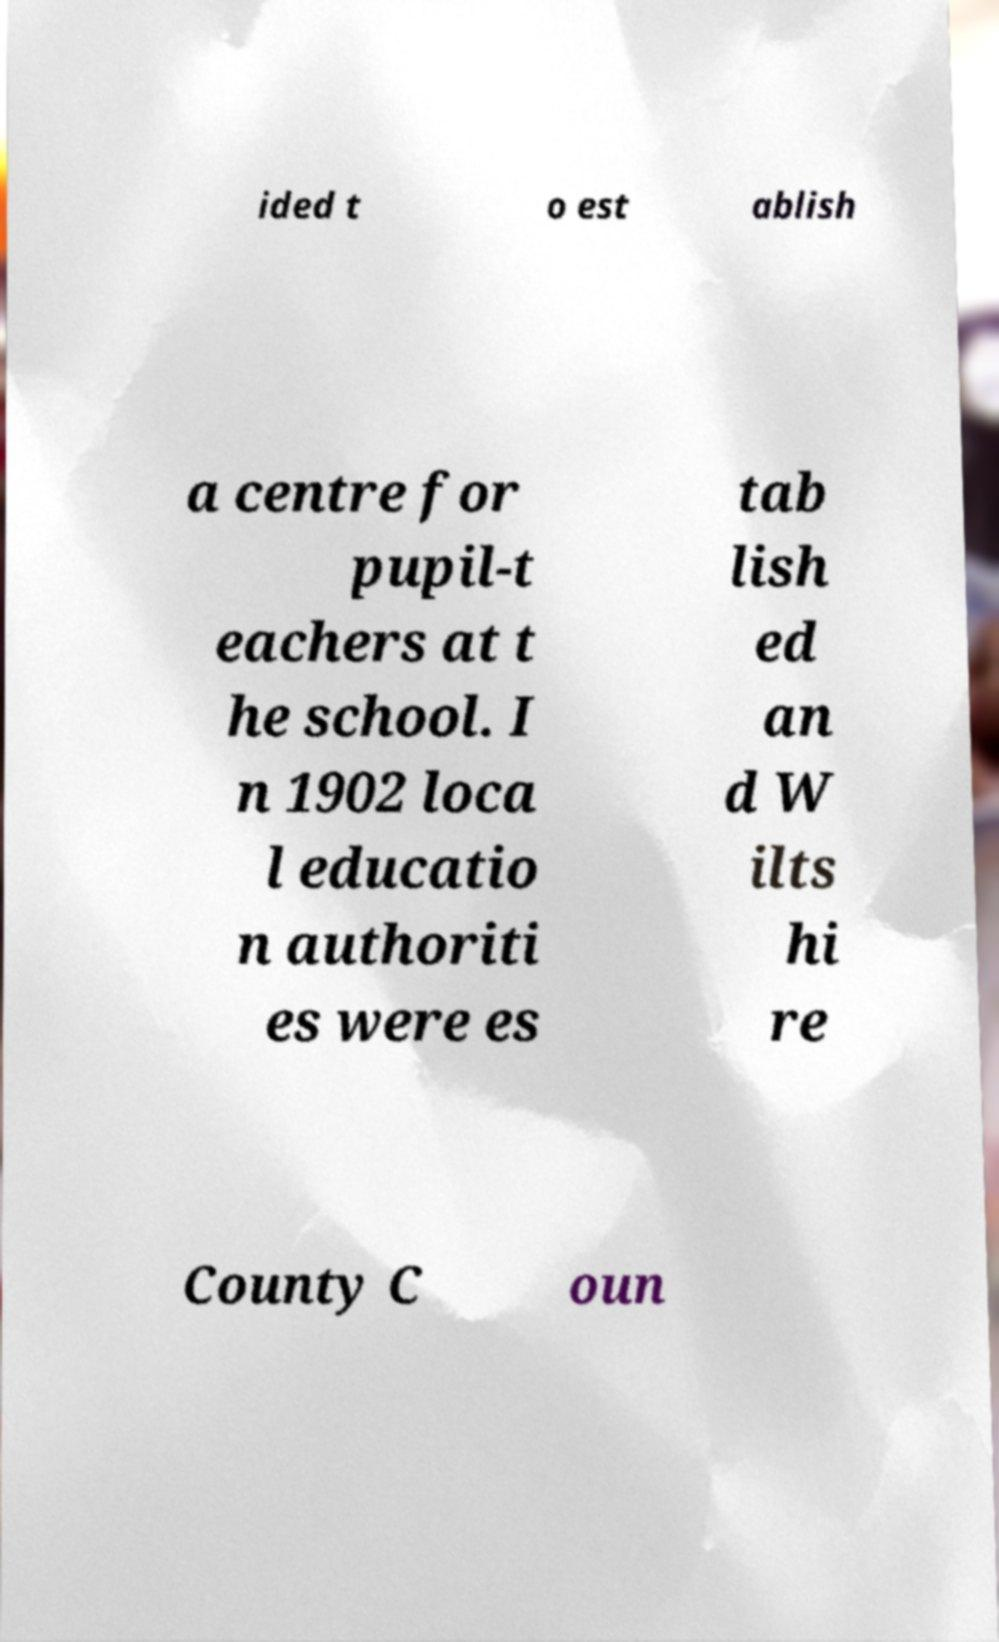Can you accurately transcribe the text from the provided image for me? ided t o est ablish a centre for pupil-t eachers at t he school. I n 1902 loca l educatio n authoriti es were es tab lish ed an d W ilts hi re County C oun 